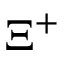Convert formula to latex. <formula><loc_0><loc_0><loc_500><loc_500>\Xi ^ { + }</formula> 